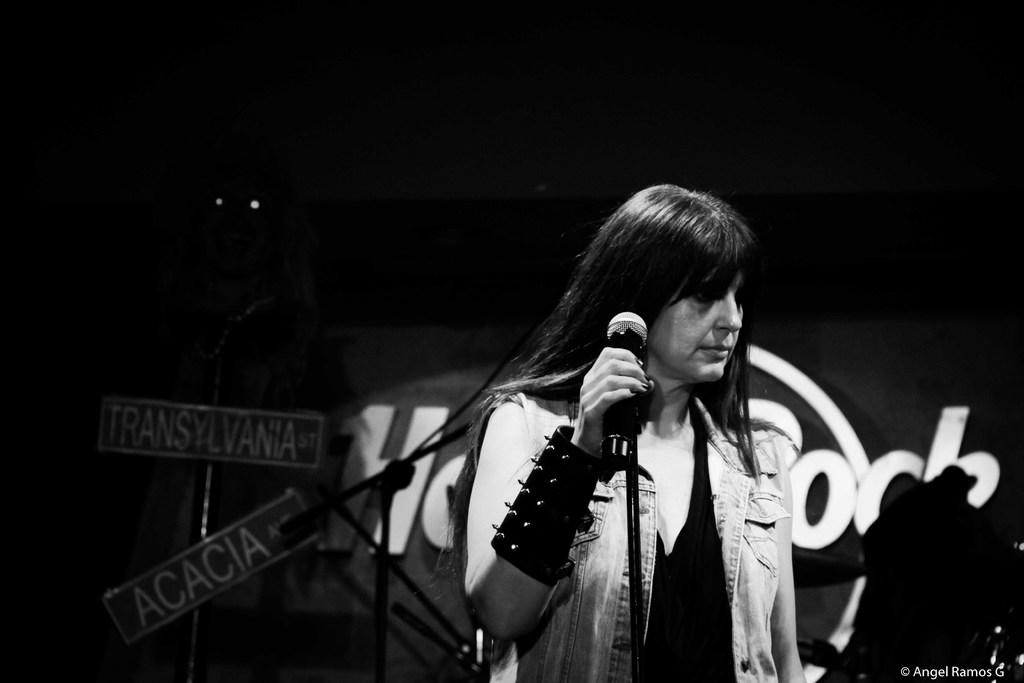What is the main subject of the image? There is a woman standing in the center of the image. What is the woman holding in the image? The woman is holding a microphone. What can be seen in the background of the image? There are sign boards, a banner, and other objects visible in the background of the image. How many pizzas are being served on the table in the image? There is no table or pizzas present in the image. 